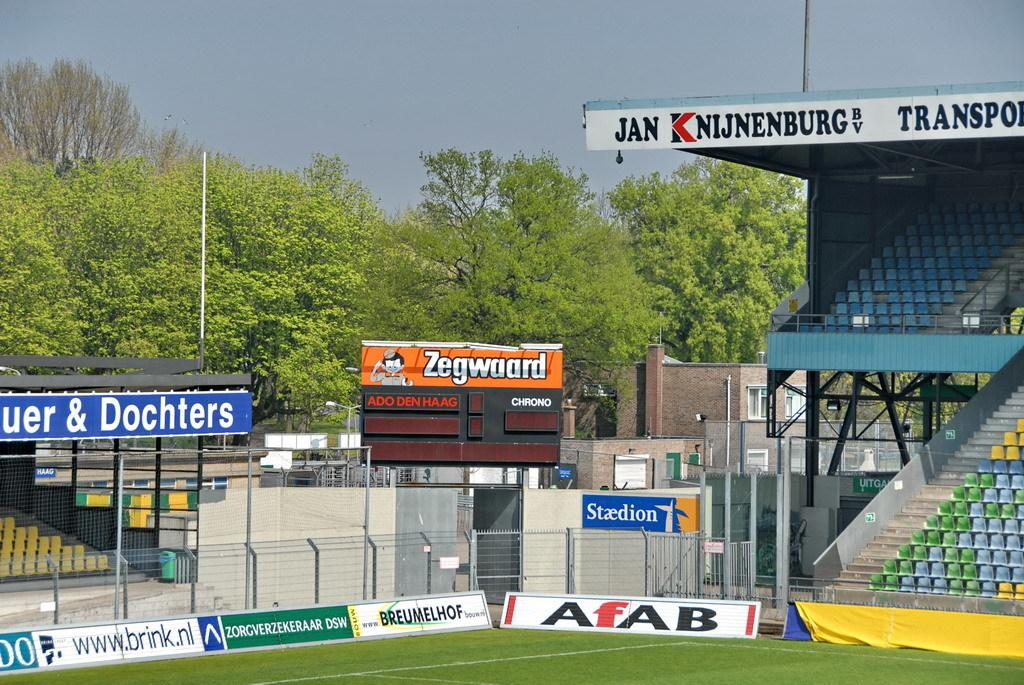<image>
Describe the image concisely. A soccer stadium with various advertisements that are in German. 